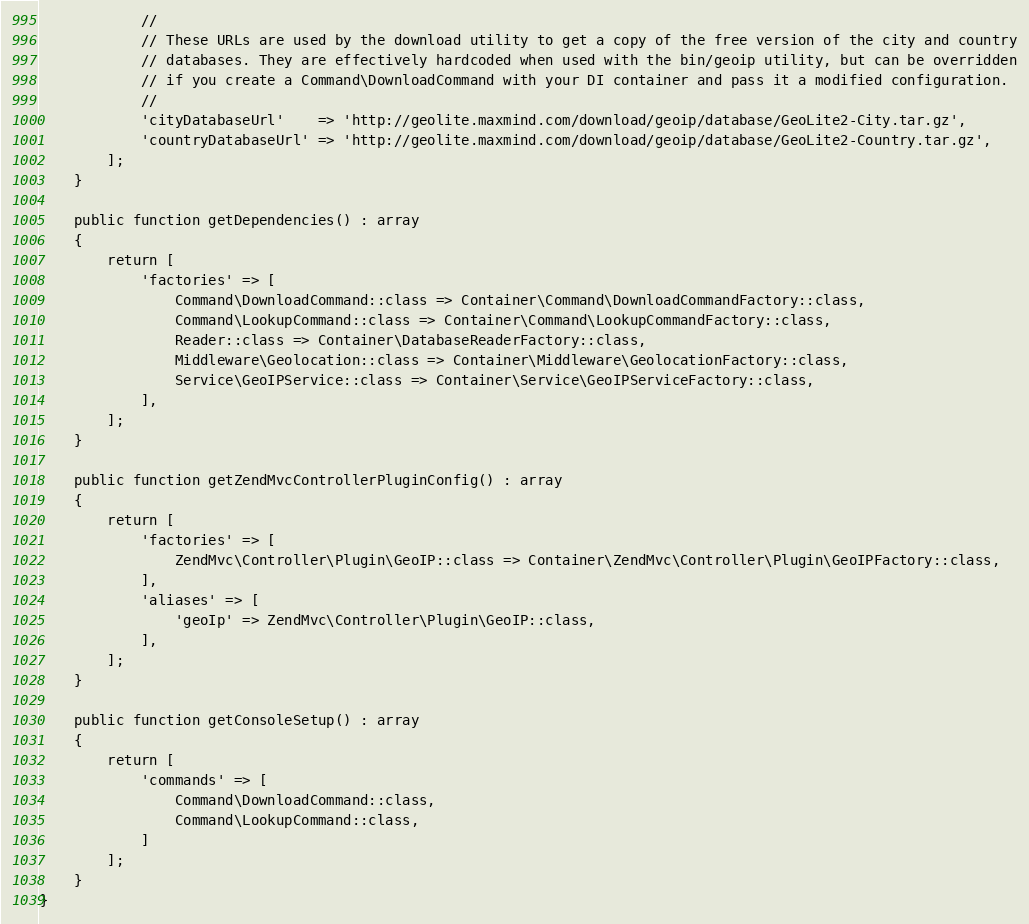Convert code to text. <code><loc_0><loc_0><loc_500><loc_500><_PHP_>            //
            // These URLs are used by the download utility to get a copy of the free version of the city and country
            // databases. They are effectively hardcoded when used with the bin/geoip utility, but can be overridden
            // if you create a Command\DownloadCommand with your DI container and pass it a modified configuration.
            //
            'cityDatabaseUrl'    => 'http://geolite.maxmind.com/download/geoip/database/GeoLite2-City.tar.gz',
            'countryDatabaseUrl' => 'http://geolite.maxmind.com/download/geoip/database/GeoLite2-Country.tar.gz',
        ];
    }

    public function getDependencies() : array
    {
        return [
            'factories' => [
                Command\DownloadCommand::class => Container\Command\DownloadCommandFactory::class,
                Command\LookupCommand::class => Container\Command\LookupCommandFactory::class,
                Reader::class => Container\DatabaseReaderFactory::class,
                Middleware\Geolocation::class => Container\Middleware\GeolocationFactory::class,
                Service\GeoIPService::class => Container\Service\GeoIPServiceFactory::class,
            ],
        ];
    }

    public function getZendMvcControllerPluginConfig() : array
    {
        return [
            'factories' => [
                ZendMvc\Controller\Plugin\GeoIP::class => Container\ZendMvc\Controller\Plugin\GeoIPFactory::class,
            ],
            'aliases' => [
                'geoIp' => ZendMvc\Controller\Plugin\GeoIP::class,
            ],
        ];
    }

    public function getConsoleSetup() : array
    {
        return [
            'commands' => [
                Command\DownloadCommand::class,
                Command\LookupCommand::class,
            ]
        ];
    }
}
</code> 